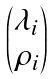<formula> <loc_0><loc_0><loc_500><loc_500>\begin{pmatrix} \lambda _ { i } \\ \rho _ { i } \end{pmatrix}</formula> 